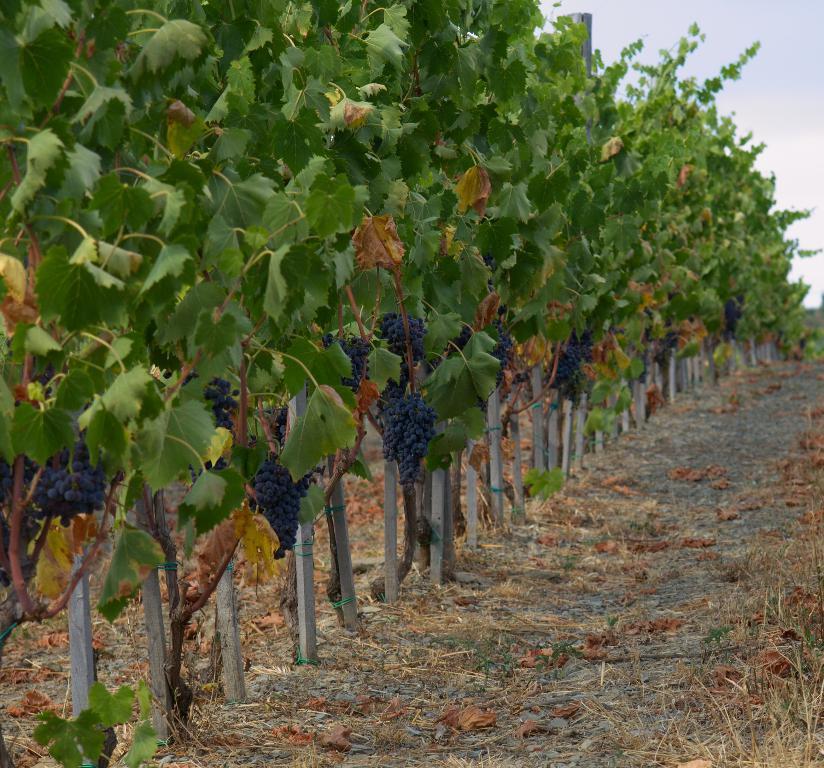In one or two sentences, can you explain what this image depicts? This picture is clicked outside. On the left we can see the bunches of grapes hanging on the trees and we can see the poles and the dry leaves. In the background there is a sky. 